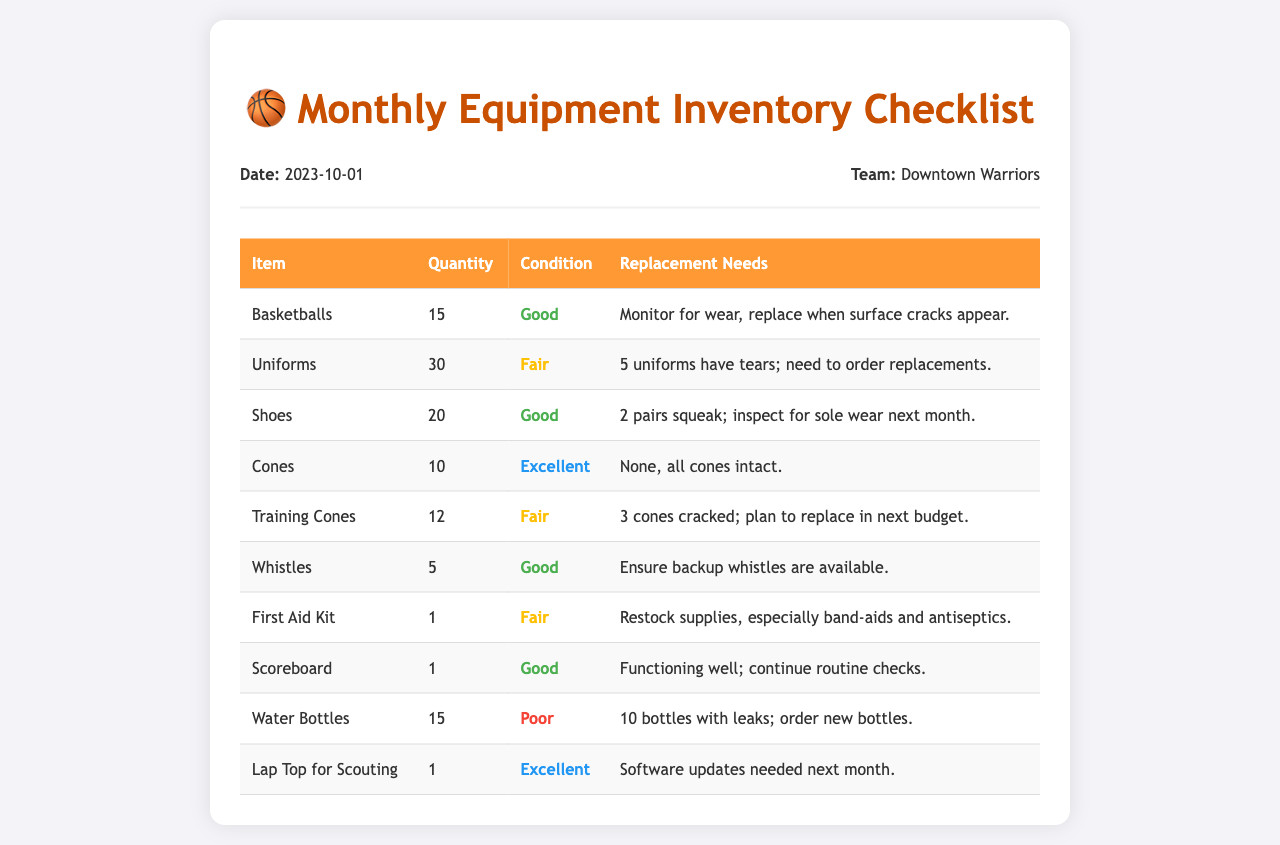What is the date of the inventory checklist? The date of the inventory checklist is provided in the header section of the document.
Answer: 2023-10-01 How many basketballs are available? The quantity of basketballs is listed in the table under the 'Quantity' column.
Answer: 15 What is the condition of the uniforms? The condition of the uniforms is specified in the table next to the item name.
Answer: Fair How many water bottles are in poor condition? The number of water bottles in poor condition is noted in the table.
Answer: 10 What item needs software updates next month? The item requiring software updates is found in the 'Replacement Needs' section of the table.
Answer: Lap Top for Scouting Which item has a total quantity of 12? The quantity of 12 is specified for an item in the first column of the table.
Answer: Training Cones What is the condition assessment for the scoreboard? The condition assessment for the scoreboard is stated in the table next to the item.
Answer: Good How many uniforms need to be replaced? The number of uniforms requiring replacement is detailed in the 'Replacement Needs' for that item.
Answer: 5 What needs to be restocked in the first aid kit? The items needing restock are mentioned in the 'Replacement Needs' section of the first aid kit row.
Answer: Band-aids and antiseptics 